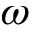Convert formula to latex. <formula><loc_0><loc_0><loc_500><loc_500>\omega</formula> 